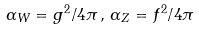Convert formula to latex. <formula><loc_0><loc_0><loc_500><loc_500>\alpha _ { W } = g ^ { 2 } / 4 \pi \, , \, \alpha _ { Z } = f ^ { 2 } / 4 \pi</formula> 